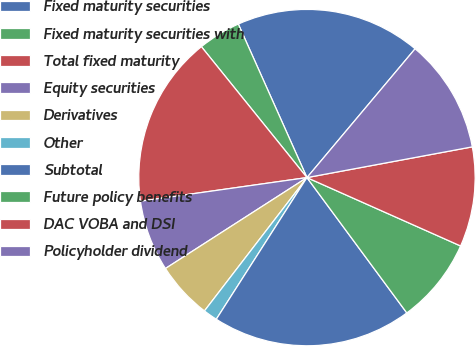<chart> <loc_0><loc_0><loc_500><loc_500><pie_chart><fcel>Fixed maturity securities<fcel>Fixed maturity securities with<fcel>Total fixed maturity<fcel>Equity securities<fcel>Derivatives<fcel>Other<fcel>Subtotal<fcel>Future policy benefits<fcel>DAC VOBA and DSI<fcel>Policyholder dividend<nl><fcel>17.81%<fcel>4.11%<fcel>16.44%<fcel>6.85%<fcel>5.48%<fcel>1.37%<fcel>19.18%<fcel>8.22%<fcel>9.59%<fcel>10.96%<nl></chart> 